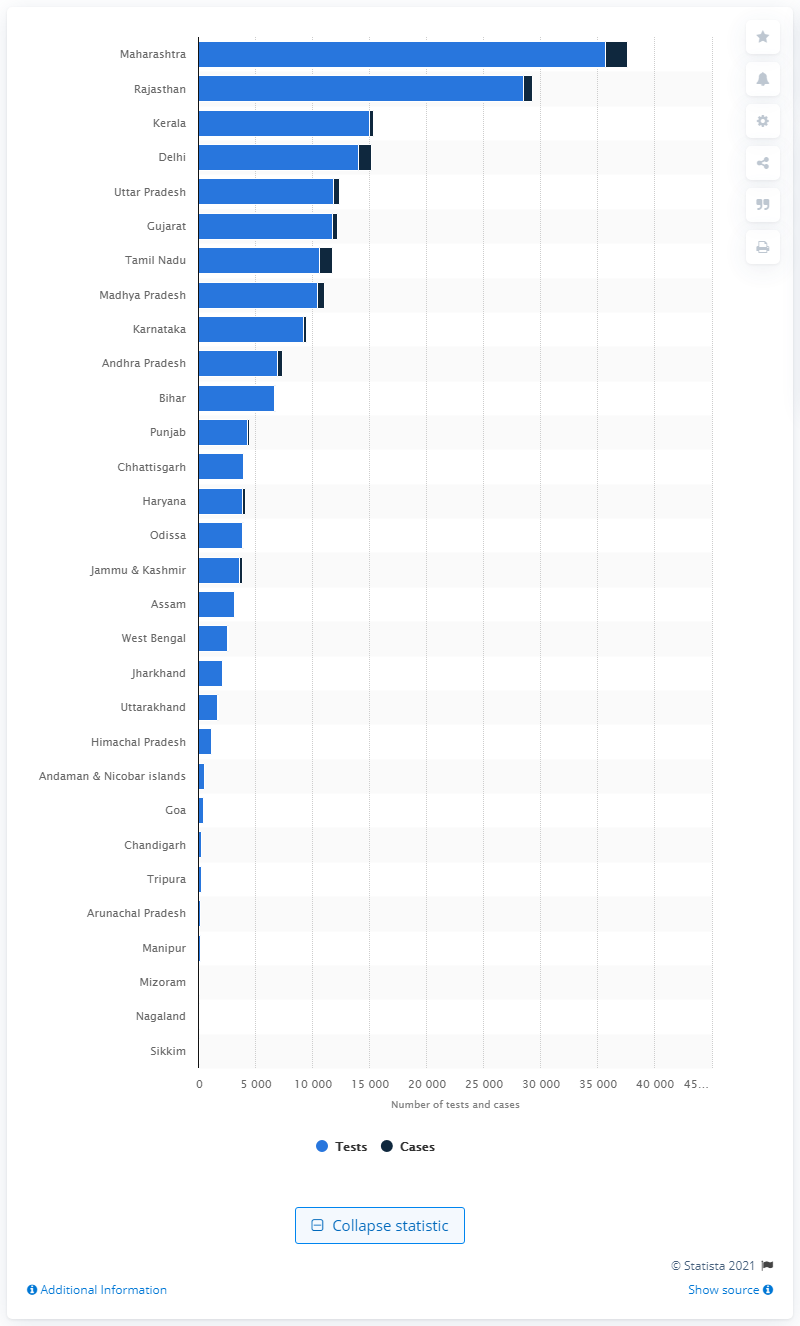Draw attention to some important aspects in this diagram. Sikkim conducted the minimum number of tests with zero cases detected. 